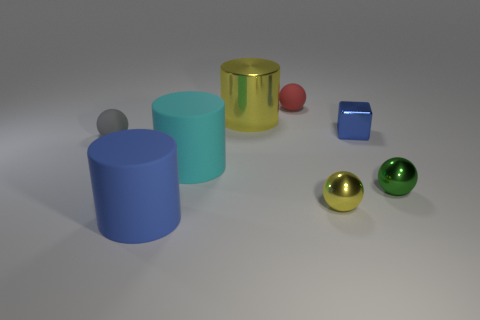Is there anything in the image that indicates size or scale? The image doesn't have any clear indicators of size or scale, such as familiar objects or a background to provide context. All the objects are depicted in an isolated manner, floating against a nondescript background, which makes it challenging to determine their actual size or the scale of the scene. 